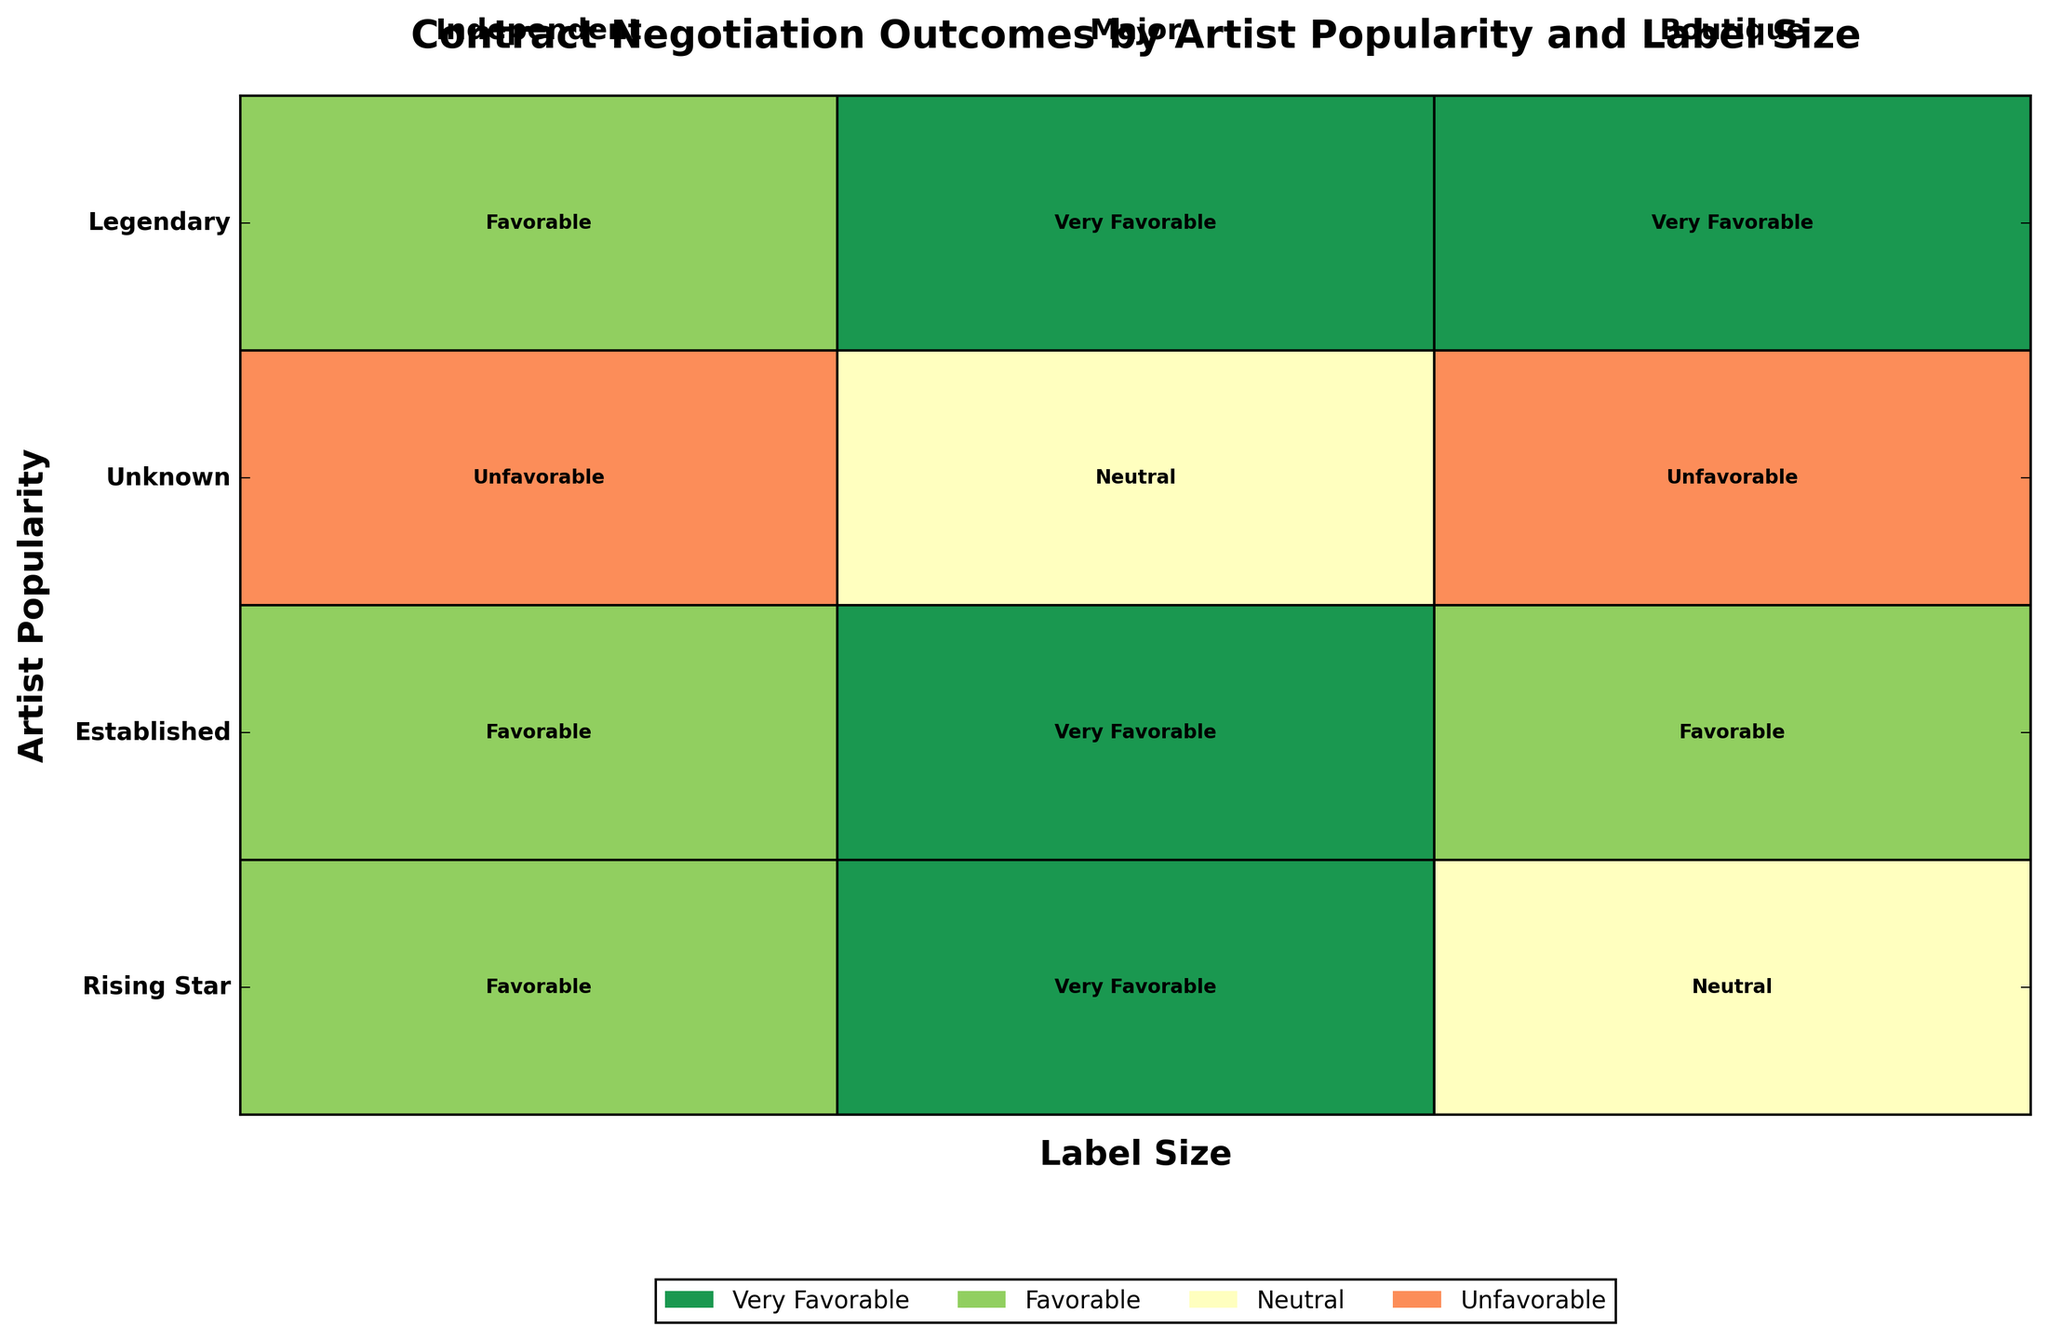What is the title of the figure? The title of the figure is displayed prominently at the top. It is a descriptive heading summarizing the content of the plot.
Answer: Contract Negotiation Outcomes by Artist Popularity and Label Size How many artist popularity categories are represented in the figure? The y-axis of the plot lists the different categories of artist popularity. By counting these categories, you can determine the total number.
Answer: Four Which negotiation outcome has the darkest color in the figure? The plot's legend associates each negotiation outcome with a specific color. The darkest color corresponds to the "Very Favorable" outcome.
Answer: Very Favorable Which artist popularity category has the highest proportion of 'Unfavorable' negotiation outcomes across all label sizes? To identify this, observe each row corresponding to artist popularity categories and compare the width of the 'Unfavorable' sections colored in a specific shade. The widest 'Unfavorable' section indicates the highest proportion.
Answer: Unknown What proportion of 'Very Favorable' outcomes do 'Legendary' artists have with 'Boutique' label sizes? Locate the row for 'Legendary' artists and the segment for 'Boutique' labels within that row. Identify the width of the 'Very Favorable' section within this intersection.
Answer: 1/3 (since 'Very Favorable' occupies the entire breadth for 'Boutique' labels within 'Legendary' artists) Which label size has the most diverse negotiation outcomes for 'Rising Star' artists? Examine the row for 'Rising Star' artists and observe the distribution of the different negotiation outcome colors across different label sizes. The diversity can be evaluated by the presence of more segments with distinct colors.
Answer: Major How does the proportion of 'Neutral' outcomes compare between 'Established' artists and 'Rising Star' artists? Compare the width of the 'Neutral' (yellow color) sections in the rows corresponding to 'Established' and 'Rising Star'. Determine which one has a longer yellow section.
Answer: 'Rising Star' has a greater proportion Which negotiation outcome color appears the most frequently overall in the figure? Scan across all rows and note the occurrences of each color. The most frequent color by visual inspection corresponds to the most common outcome.
Answer: Favorable (green) Do 'Independent' labels have any 'Very Favorable' outcomes for 'Rising Star' artists? Look at the intersection of the 'Rising Star' row with the 'Independent' label section and check if there is any segment colored in the shade representing 'Very Favorable'.
Answer: No For 'Legendary' artists, which label size offers the most 'Favorable' outcomes? Examine the 'Legendary' row and check the width of the 'Favorable' (lighter green) segments across different label sizes. The one with the widest segment corresponds to the highest proportion.
Answer: Independent 